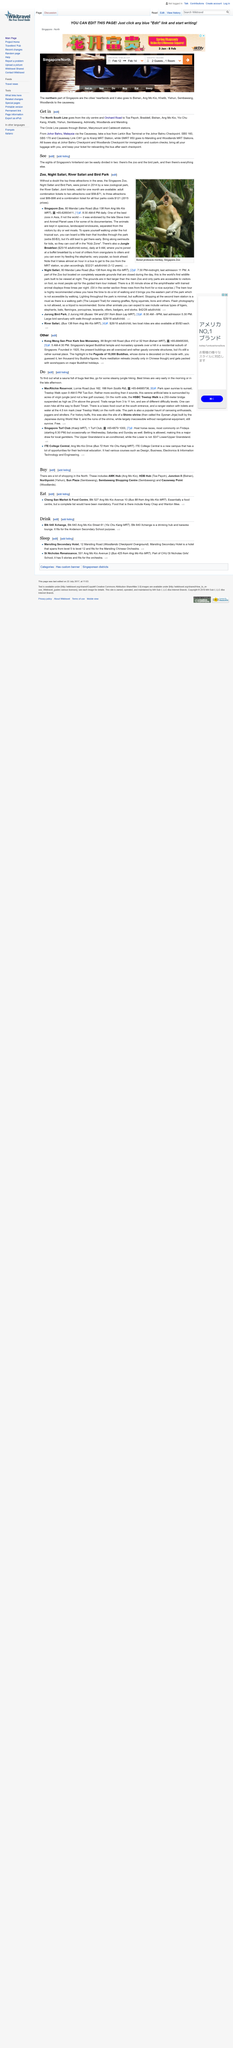Highlight a few significant elements in this photo. It is advisable to retain your ticket as it enables you to board the bus again after each checkpoint. MacRitchie Reservoir is a popular destination for steamy jungle hiking, offering visitors the opportunity to explore the lush and exotic surroundings of the Singaporean jungle. The HSBC Treetop Walk is a 250 meter bridge suspended at a height of 27 meters above the ground. The North South Line begins in the city center and Orchard Road and proceeds to its final destination. The best times to go hiking at the MacRitchie Reservoir are in the morning or in the late afternoon. 